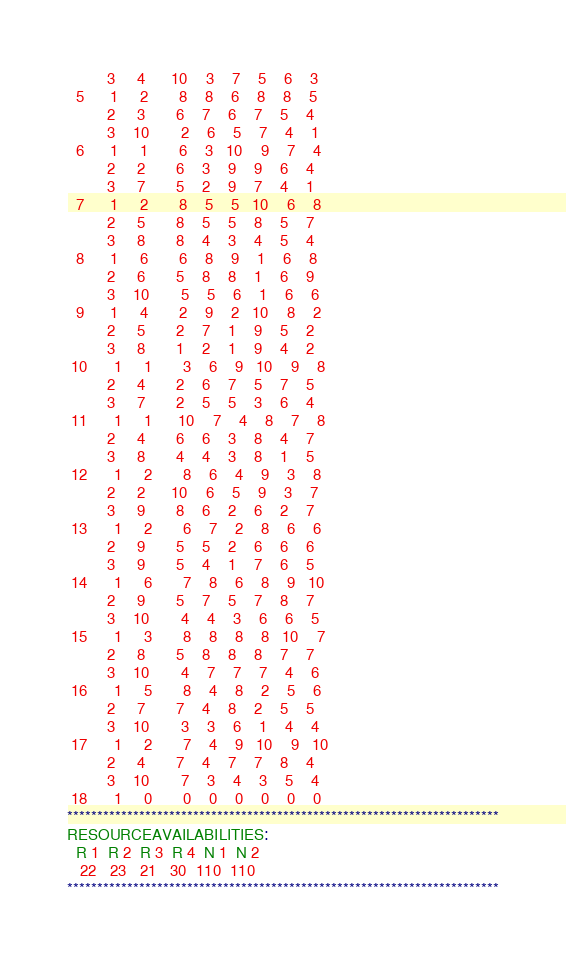<code> <loc_0><loc_0><loc_500><loc_500><_ObjectiveC_>         3     4      10    3    7    5    6    3
  5      1     2       8    8    6    8    8    5
         2     3       6    7    6    7    5    4
         3    10       2    6    5    7    4    1
  6      1     1       6    3   10    9    7    4
         2     2       6    3    9    9    6    4
         3     7       5    2    9    7    4    1
  7      1     2       8    5    5   10    6    8
         2     5       8    5    5    8    5    7
         3     8       8    4    3    4    5    4
  8      1     6       6    8    9    1    6    8
         2     6       5    8    8    1    6    9
         3    10       5    5    6    1    6    6
  9      1     4       2    9    2   10    8    2
         2     5       2    7    1    9    5    2
         3     8       1    2    1    9    4    2
 10      1     1       3    6    9   10    9    8
         2     4       2    6    7    5    7    5
         3     7       2    5    5    3    6    4
 11      1     1      10    7    4    8    7    8
         2     4       6    6    3    8    4    7
         3     8       4    4    3    8    1    5
 12      1     2       8    6    4    9    3    8
         2     2      10    6    5    9    3    7
         3     9       8    6    2    6    2    7
 13      1     2       6    7    2    8    6    6
         2     9       5    5    2    6    6    6
         3     9       5    4    1    7    6    5
 14      1     6       7    8    6    8    9   10
         2     9       5    7    5    7    8    7
         3    10       4    4    3    6    6    5
 15      1     3       8    8    8    8   10    7
         2     8       5    8    8    8    7    7
         3    10       4    7    7    7    4    6
 16      1     5       8    4    8    2    5    6
         2     7       7    4    8    2    5    5
         3    10       3    3    6    1    4    4
 17      1     2       7    4    9   10    9   10
         2     4       7    4    7    7    8    4
         3    10       7    3    4    3    5    4
 18      1     0       0    0    0    0    0    0
************************************************************************
RESOURCEAVAILABILITIES:
  R 1  R 2  R 3  R 4  N 1  N 2
   22   23   21   30  110  110
************************************************************************
</code> 